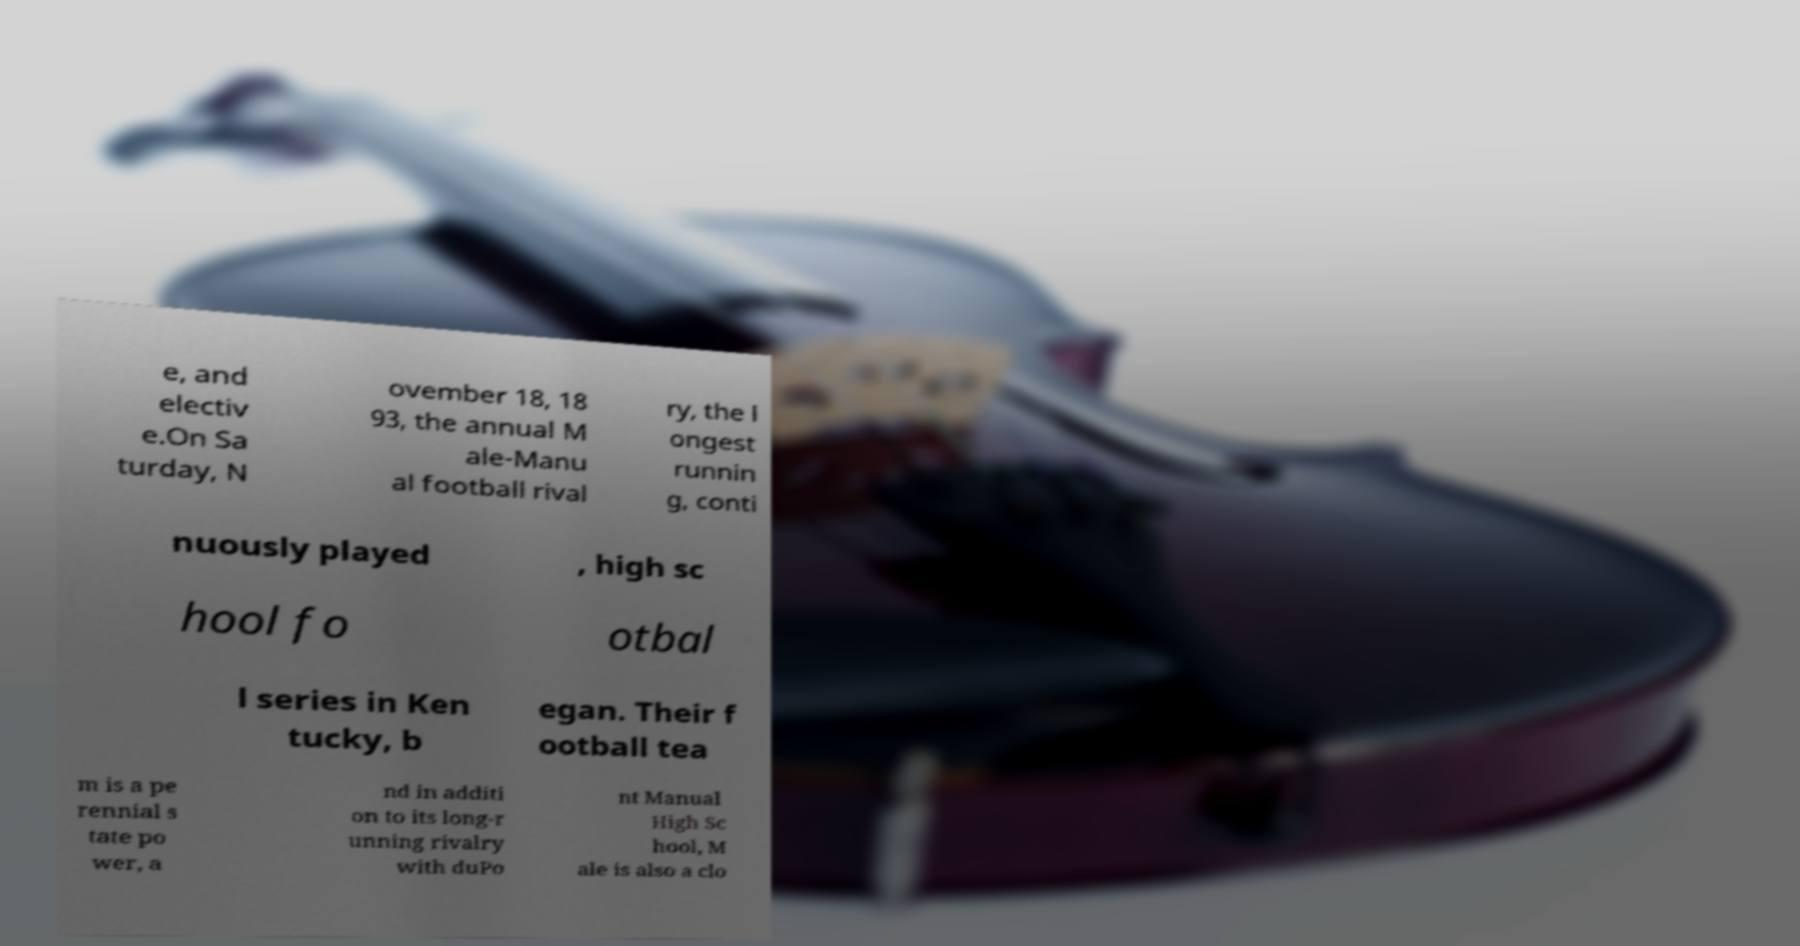Can you accurately transcribe the text from the provided image for me? e, and electiv e.On Sa turday, N ovember 18, 18 93, the annual M ale-Manu al football rival ry, the l ongest runnin g, conti nuously played , high sc hool fo otbal l series in Ken tucky, b egan. Their f ootball tea m is a pe rennial s tate po wer, a nd in additi on to its long-r unning rivalry with duPo nt Manual High Sc hool, M ale is also a clo 